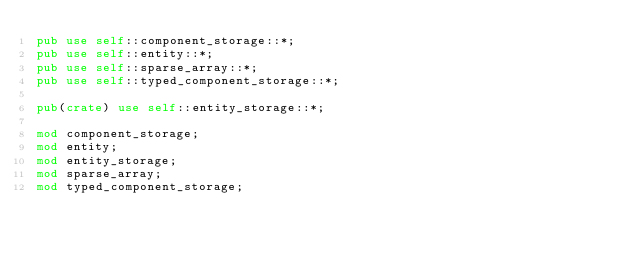<code> <loc_0><loc_0><loc_500><loc_500><_Rust_>pub use self::component_storage::*;
pub use self::entity::*;
pub use self::sparse_array::*;
pub use self::typed_component_storage::*;

pub(crate) use self::entity_storage::*;

mod component_storage;
mod entity;
mod entity_storage;
mod sparse_array;
mod typed_component_storage;
</code> 